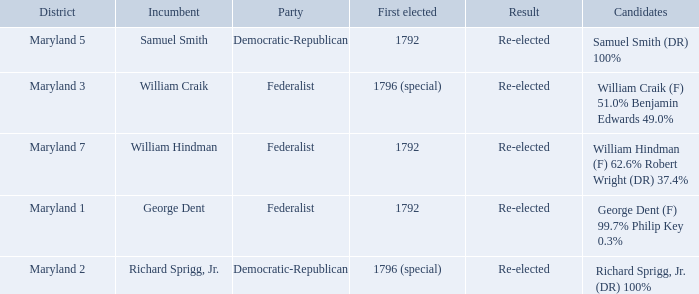What is the party when the incumbent is samuel smith? Democratic-Republican. Can you give me this table as a dict? {'header': ['District', 'Incumbent', 'Party', 'First elected', 'Result', 'Candidates'], 'rows': [['Maryland 5', 'Samuel Smith', 'Democratic-Republican', '1792', 'Re-elected', 'Samuel Smith (DR) 100%'], ['Maryland 3', 'William Craik', 'Federalist', '1796 (special)', 'Re-elected', 'William Craik (F) 51.0% Benjamin Edwards 49.0%'], ['Maryland 7', 'William Hindman', 'Federalist', '1792', 'Re-elected', 'William Hindman (F) 62.6% Robert Wright (DR) 37.4%'], ['Maryland 1', 'George Dent', 'Federalist', '1792', 'Re-elected', 'George Dent (F) 99.7% Philip Key 0.3%'], ['Maryland 2', 'Richard Sprigg, Jr.', 'Democratic-Republican', '1796 (special)', 'Re-elected', 'Richard Sprigg, Jr. (DR) 100%']]} 